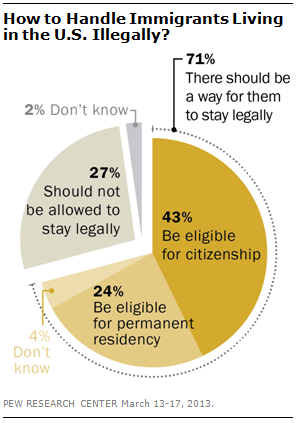Point out several critical features in this image. According to the data, only 0.43% of individuals are eligible for citizenship. 0.43% of eligible individuals are currently eligible for citizenship. 